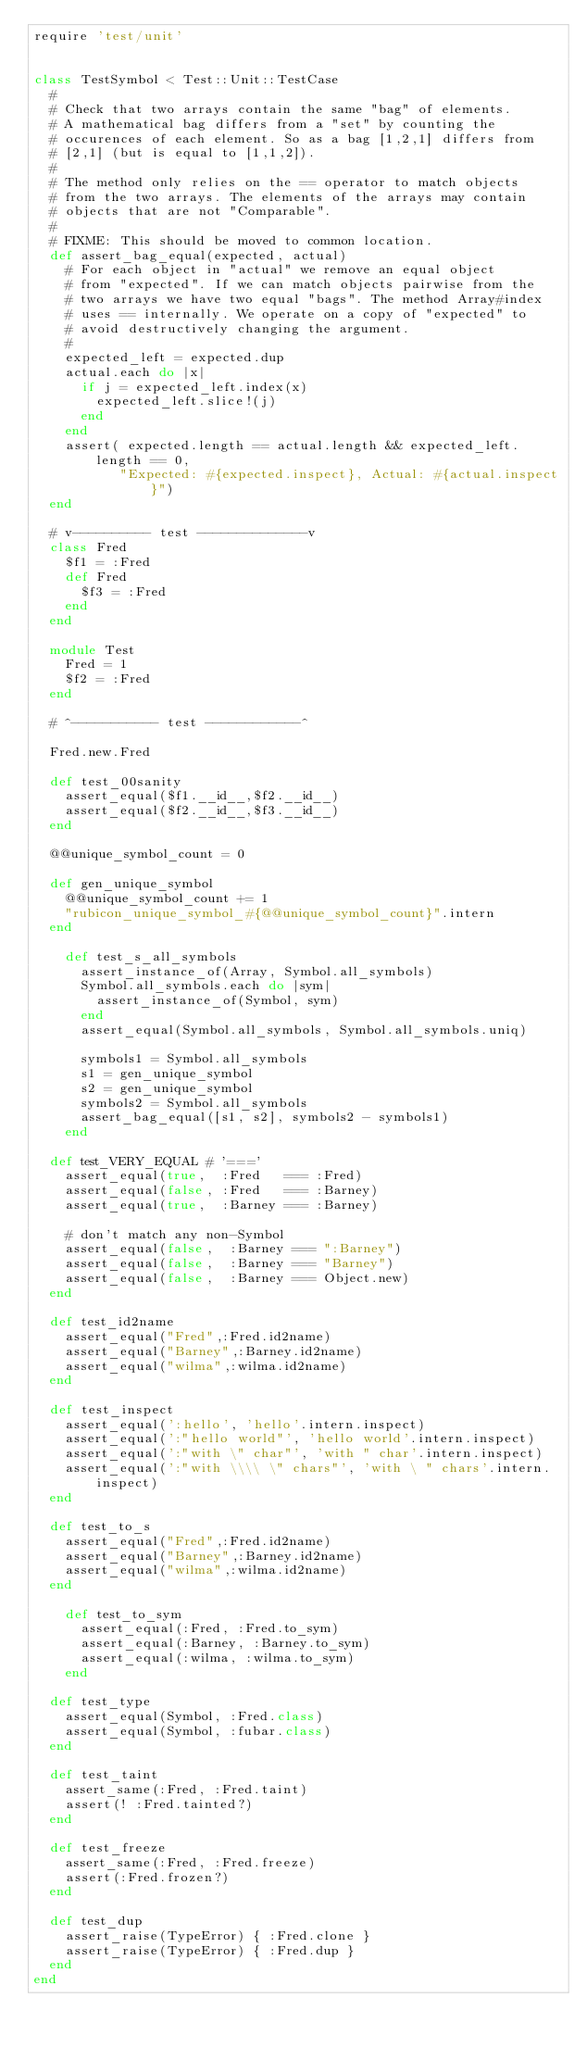<code> <loc_0><loc_0><loc_500><loc_500><_Ruby_>require 'test/unit'


class TestSymbol < Test::Unit::TestCase
  #
  # Check that two arrays contain the same "bag" of elements.
  # A mathematical bag differs from a "set" by counting the
  # occurences of each element. So as a bag [1,2,1] differs from
  # [2,1] (but is equal to [1,1,2]).
  #
  # The method only relies on the == operator to match objects
  # from the two arrays. The elements of the arrays may contain
  # objects that are not "Comparable".
  #
  # FIXME: This should be moved to common location.
  def assert_bag_equal(expected, actual)
    # For each object in "actual" we remove an equal object
    # from "expected". If we can match objects pairwise from the
    # two arrays we have two equal "bags". The method Array#index
    # uses == internally. We operate on a copy of "expected" to
    # avoid destructively changing the argument.
    #
    expected_left = expected.dup
    actual.each do |x|
      if j = expected_left.index(x)
        expected_left.slice!(j)
      end
    end
    assert( expected.length == actual.length && expected_left.length == 0,
           "Expected: #{expected.inspect}, Actual: #{actual.inspect}")
  end

  # v---------- test --------------v
  class Fred
    $f1 = :Fred
    def Fred
      $f3 = :Fred
    end
  end
  
  module Test
    Fred = 1
    $f2 = :Fred
  end
  
  # ^----------- test ------------^

  Fred.new.Fred

  def test_00sanity
    assert_equal($f1.__id__,$f2.__id__)
    assert_equal($f2.__id__,$f3.__id__)
  end

  @@unique_symbol_count = 0

  def gen_unique_symbol
    @@unique_symbol_count += 1
    "rubicon_unique_symbol_#{@@unique_symbol_count}".intern
  end

    def test_s_all_symbols
      assert_instance_of(Array, Symbol.all_symbols)
      Symbol.all_symbols.each do |sym|
        assert_instance_of(Symbol, sym)
      end
      assert_equal(Symbol.all_symbols, Symbol.all_symbols.uniq)

      symbols1 = Symbol.all_symbols
      s1 = gen_unique_symbol
      s2 = gen_unique_symbol
      symbols2 = Symbol.all_symbols
      assert_bag_equal([s1, s2], symbols2 - symbols1)
    end

  def test_VERY_EQUAL # '==='
    assert_equal(true,  :Fred   === :Fred)
    assert_equal(false, :Fred   === :Barney)
    assert_equal(true,  :Barney === :Barney)

    # don't match any non-Symbol
    assert_equal(false,  :Barney === ":Barney")
    assert_equal(false,  :Barney === "Barney")
    assert_equal(false,  :Barney === Object.new)
  end

  def test_id2name
    assert_equal("Fred",:Fred.id2name)
    assert_equal("Barney",:Barney.id2name)
    assert_equal("wilma",:wilma.id2name)
  end

  def test_inspect
    assert_equal(':hello', 'hello'.intern.inspect)
    assert_equal(':"hello world"', 'hello world'.intern.inspect)
    assert_equal(':"with \" char"', 'with " char'.intern.inspect)
    assert_equal(':"with \\\\ \" chars"', 'with \ " chars'.intern.inspect)
  end

  def test_to_s
    assert_equal("Fred",:Fred.id2name)
    assert_equal("Barney",:Barney.id2name)
    assert_equal("wilma",:wilma.id2name)
  end

    def test_to_sym
      assert_equal(:Fred, :Fred.to_sym)
      assert_equal(:Barney, :Barney.to_sym)
      assert_equal(:wilma, :wilma.to_sym)
    end

  def test_type
    assert_equal(Symbol, :Fred.class)
    assert_equal(Symbol, :fubar.class)
  end

  def test_taint
    assert_same(:Fred, :Fred.taint)
    assert(! :Fred.tainted?)
  end

  def test_freeze
    assert_same(:Fred, :Fred.freeze)
    assert(:Fred.frozen?)
  end

  def test_dup
    assert_raise(TypeError) { :Fred.clone }
    assert_raise(TypeError) { :Fred.dup }
  end
end
</code> 